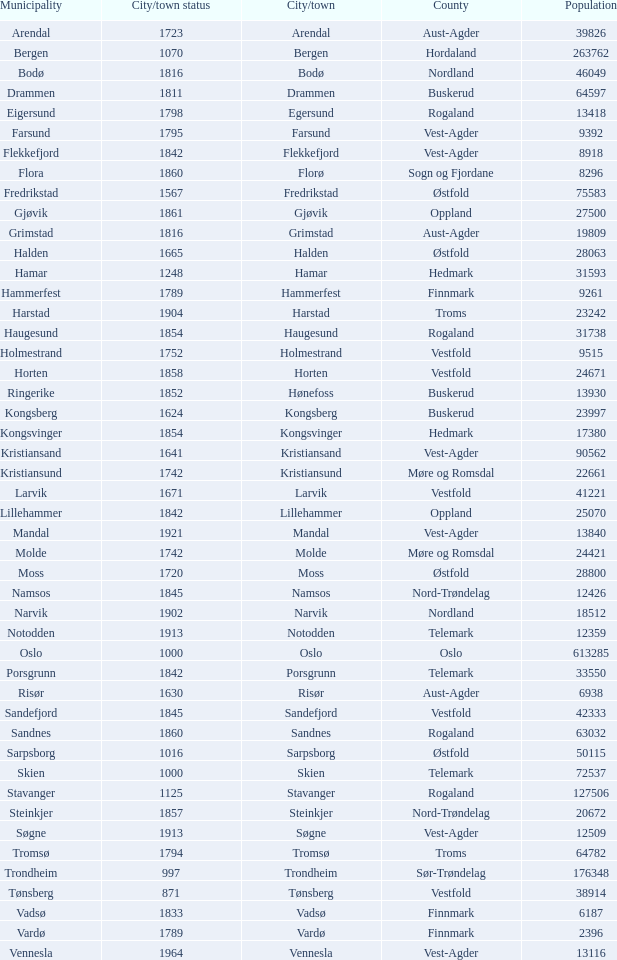Parse the full table. {'header': ['Municipality', 'City/town status', 'City/town', 'County', 'Population'], 'rows': [['Arendal', '1723', 'Arendal', 'Aust-Agder', '39826'], ['Bergen', '1070', 'Bergen', 'Hordaland', '263762'], ['Bodø', '1816', 'Bodø', 'Nordland', '46049'], ['Drammen', '1811', 'Drammen', 'Buskerud', '64597'], ['Eigersund', '1798', 'Egersund', 'Rogaland', '13418'], ['Farsund', '1795', 'Farsund', 'Vest-Agder', '9392'], ['Flekkefjord', '1842', 'Flekkefjord', 'Vest-Agder', '8918'], ['Flora', '1860', 'Florø', 'Sogn og Fjordane', '8296'], ['Fredrikstad', '1567', 'Fredrikstad', 'Østfold', '75583'], ['Gjøvik', '1861', 'Gjøvik', 'Oppland', '27500'], ['Grimstad', '1816', 'Grimstad', 'Aust-Agder', '19809'], ['Halden', '1665', 'Halden', 'Østfold', '28063'], ['Hamar', '1248', 'Hamar', 'Hedmark', '31593'], ['Hammerfest', '1789', 'Hammerfest', 'Finnmark', '9261'], ['Harstad', '1904', 'Harstad', 'Troms', '23242'], ['Haugesund', '1854', 'Haugesund', 'Rogaland', '31738'], ['Holmestrand', '1752', 'Holmestrand', 'Vestfold', '9515'], ['Horten', '1858', 'Horten', 'Vestfold', '24671'], ['Ringerike', '1852', 'Hønefoss', 'Buskerud', '13930'], ['Kongsberg', '1624', 'Kongsberg', 'Buskerud', '23997'], ['Kongsvinger', '1854', 'Kongsvinger', 'Hedmark', '17380'], ['Kristiansand', '1641', 'Kristiansand', 'Vest-Agder', '90562'], ['Kristiansund', '1742', 'Kristiansund', 'Møre og Romsdal', '22661'], ['Larvik', '1671', 'Larvik', 'Vestfold', '41221'], ['Lillehammer', '1842', 'Lillehammer', 'Oppland', '25070'], ['Mandal', '1921', 'Mandal', 'Vest-Agder', '13840'], ['Molde', '1742', 'Molde', 'Møre og Romsdal', '24421'], ['Moss', '1720', 'Moss', 'Østfold', '28800'], ['Namsos', '1845', 'Namsos', 'Nord-Trøndelag', '12426'], ['Narvik', '1902', 'Narvik', 'Nordland', '18512'], ['Notodden', '1913', 'Notodden', 'Telemark', '12359'], ['Oslo', '1000', 'Oslo', 'Oslo', '613285'], ['Porsgrunn', '1842', 'Porsgrunn', 'Telemark', '33550'], ['Risør', '1630', 'Risør', 'Aust-Agder', '6938'], ['Sandefjord', '1845', 'Sandefjord', 'Vestfold', '42333'], ['Sandnes', '1860', 'Sandnes', 'Rogaland', '63032'], ['Sarpsborg', '1016', 'Sarpsborg', 'Østfold', '50115'], ['Skien', '1000', 'Skien', 'Telemark', '72537'], ['Stavanger', '1125', 'Stavanger', 'Rogaland', '127506'], ['Steinkjer', '1857', 'Steinkjer', 'Nord-Trøndelag', '20672'], ['Søgne', '1913', 'Søgne', 'Vest-Agder', '12509'], ['Tromsø', '1794', 'Tromsø', 'Troms', '64782'], ['Trondheim', '997', 'Trondheim', 'Sør-Trøndelag', '176348'], ['Tønsberg', '871', 'Tønsberg', 'Vestfold', '38914'], ['Vadsø', '1833', 'Vadsø', 'Finnmark', '6187'], ['Vardø', '1789', 'Vardø', 'Finnmark', '2396'], ['Vennesla', '1964', 'Vennesla', 'Vest-Agder', '13116']]} Which municipalities located in the county of Finnmark have populations bigger than 6187.0? Hammerfest. 